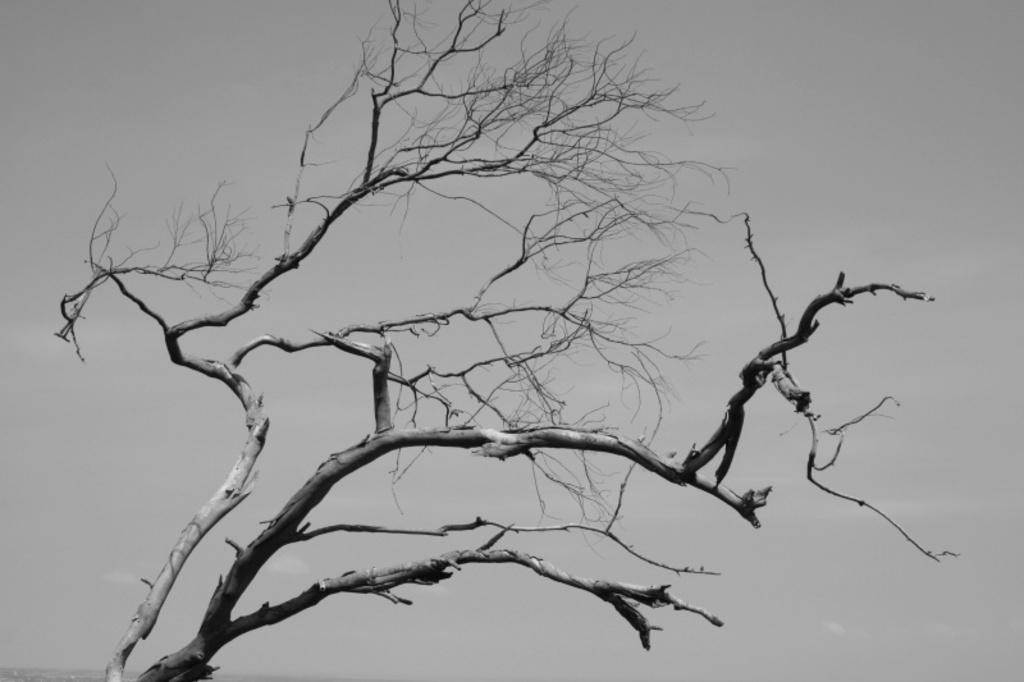How would you summarize this image in a sentence or two? This is a black and white image. In the image there is a tree with stems, branches and without leaves. 